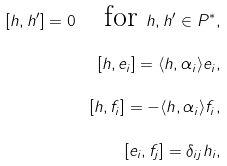Convert formula to latex. <formula><loc_0><loc_0><loc_500><loc_500>[ h , h ^ { \prime } ] = 0 \quad \text {for} \ h , h ^ { \prime } \in P ^ { * } , \\ [ h , e _ { i } ] = \langle h , \alpha _ { i } \rangle e _ { i } , \\ [ h , f _ { i } ] = - \langle h , \alpha _ { i } \rangle f _ { i } , \\ [ e _ { i } , f _ { j } ] = \delta _ { i j } h _ { i } ,</formula> 